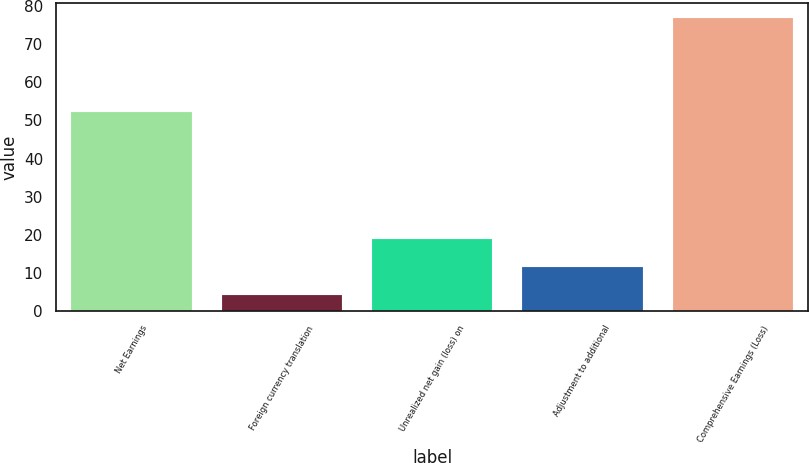<chart> <loc_0><loc_0><loc_500><loc_500><bar_chart><fcel>Net Earnings<fcel>Foreign currency translation<fcel>Unrealized net gain (loss) on<fcel>Adjustment to additional<fcel>Comprehensive Earnings (Loss)<nl><fcel>52.2<fcel>4.2<fcel>18.74<fcel>11.47<fcel>76.9<nl></chart> 